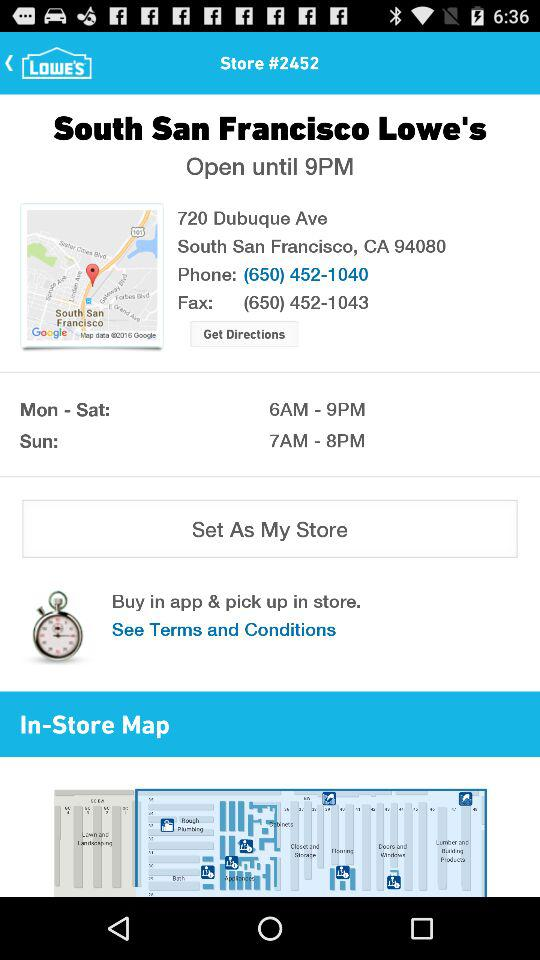What is the name of the store? The name of the store is "South San Francisco Lowe's". 